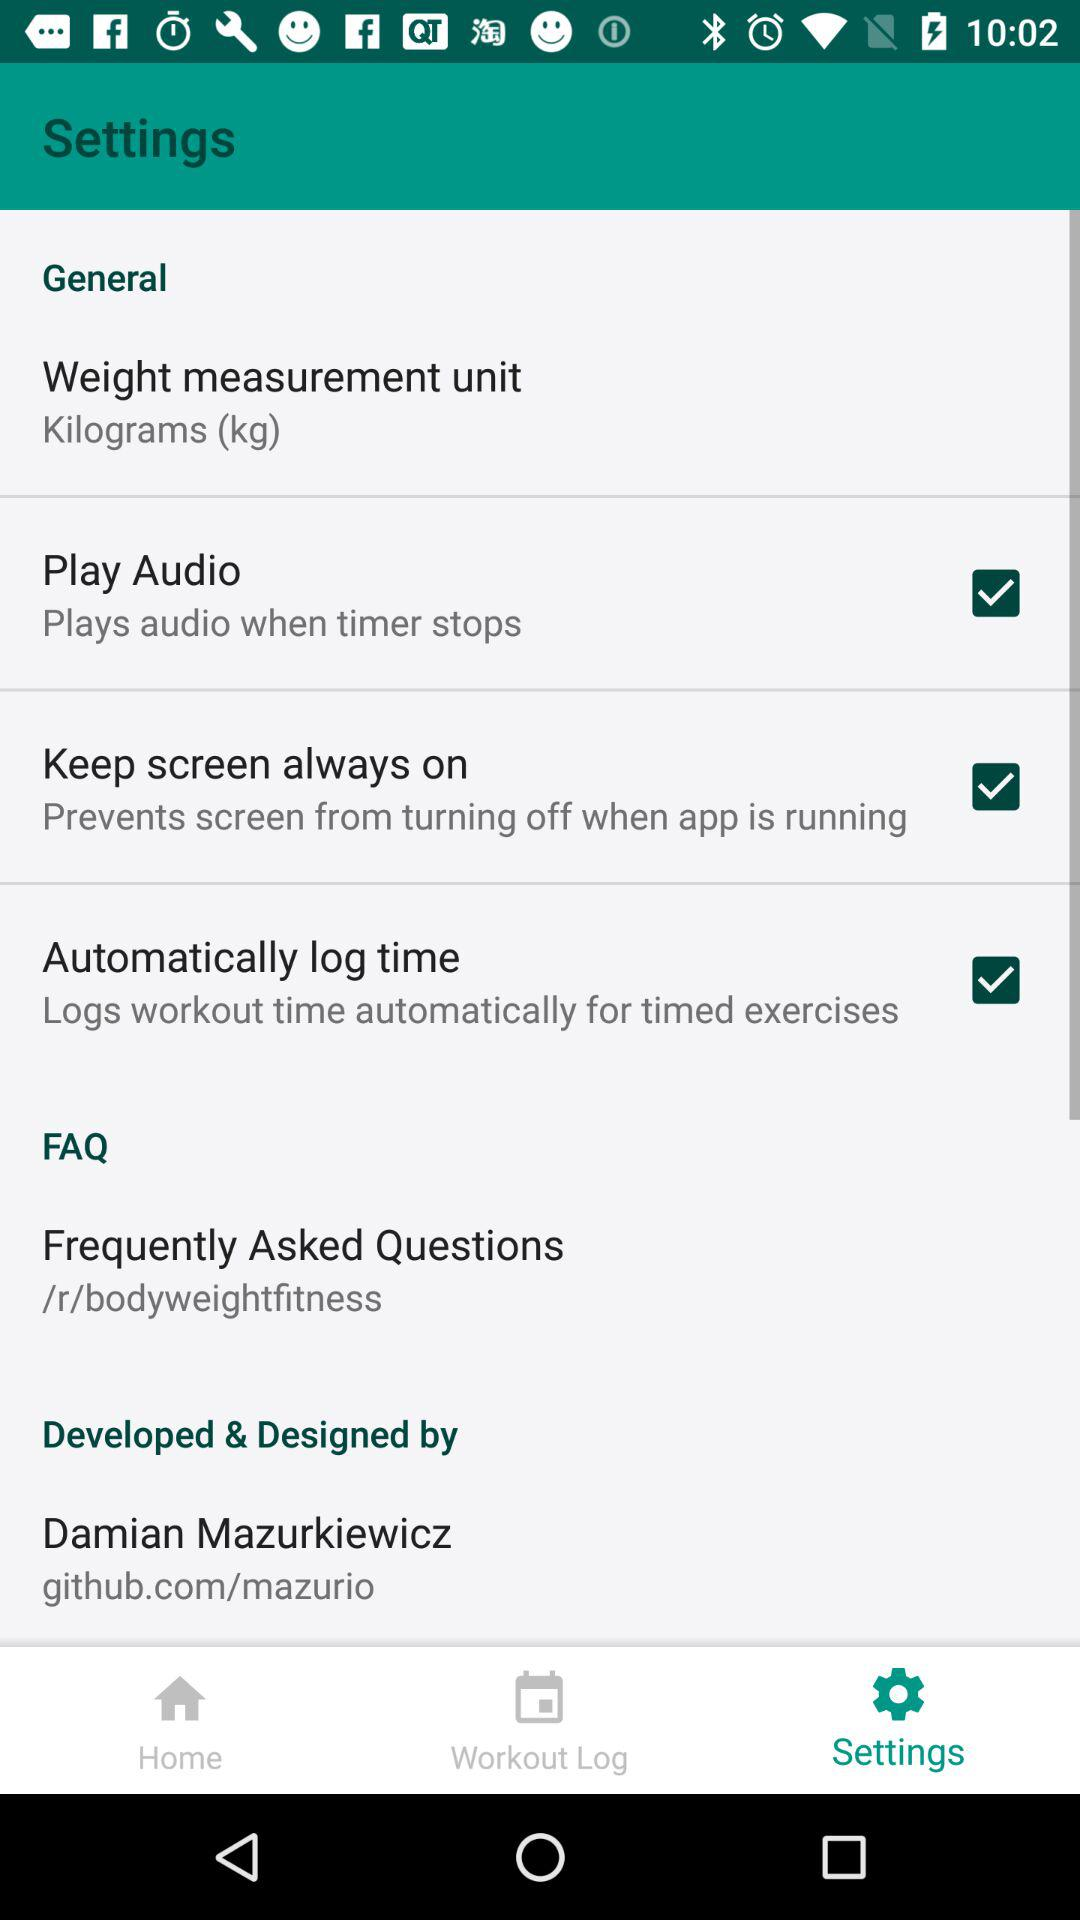Which unit of weight measurement is chosen? The chosen unit of weight measurement is the kilogram. 